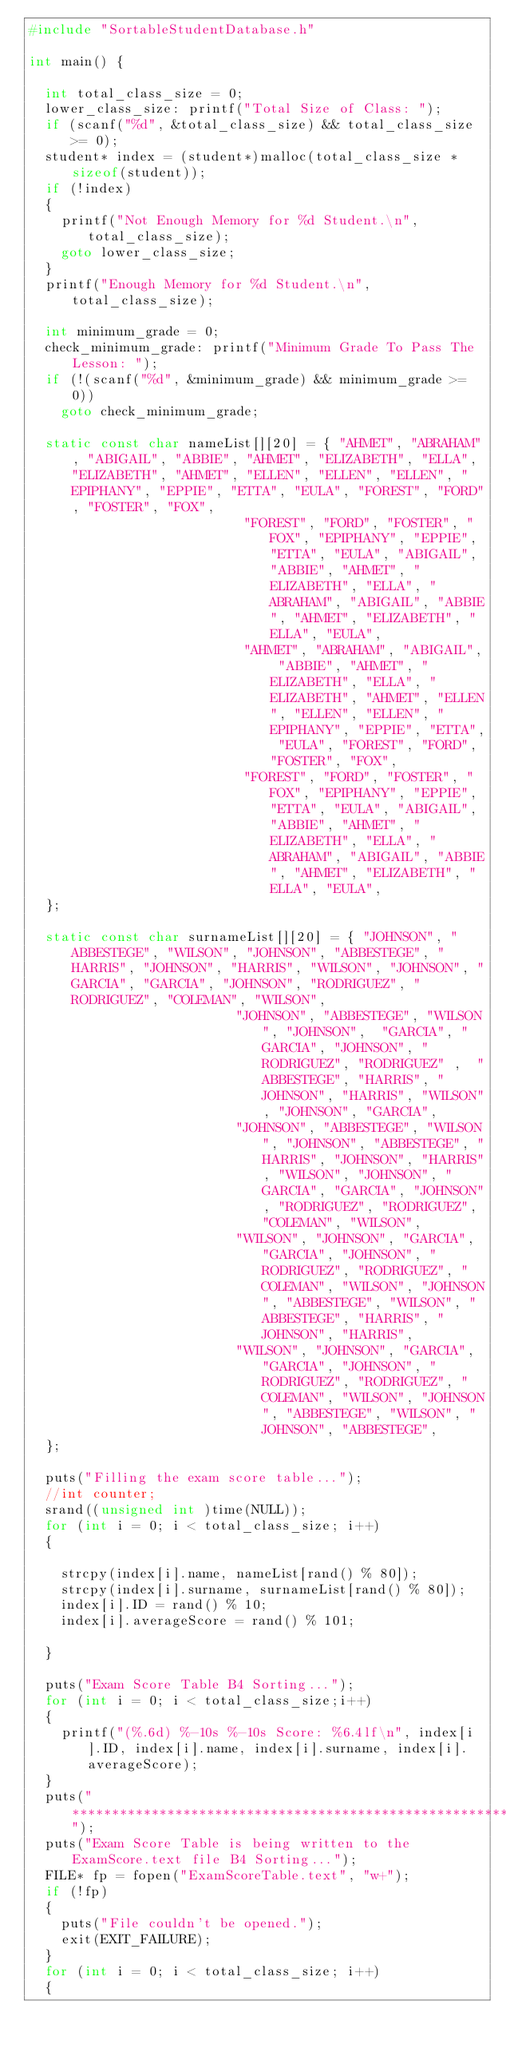Convert code to text. <code><loc_0><loc_0><loc_500><loc_500><_C_>#include "SortableStudentDatabase.h"

int main() {

	int total_class_size = 0;
	lower_class_size: printf("Total Size of Class: ");
	if (scanf("%d", &total_class_size) && total_class_size >= 0);
	student* index = (student*)malloc(total_class_size * sizeof(student));
	if (!index)
	{
		printf("Not Enough Memory for %d Student.\n", total_class_size);
		goto lower_class_size;
	}
	printf("Enough Memory for %d Student.\n", total_class_size);

	int minimum_grade = 0;
	check_minimum_grade: printf("Minimum Grade To Pass The Lesson: ");
	if (!(scanf("%d", &minimum_grade) && minimum_grade >= 0))
		goto check_minimum_grade;

	static const char nameList[][20] = { "AHMET", "ABRAHAM", "ABIGAIL", "ABBIE", "AHMET", "ELIZABETH", "ELLA", "ELIZABETH", "AHMET", "ELLEN", "ELLEN", "ELLEN", "EPIPHANY", "EPPIE", "ETTA", "EULA", "FOREST", "FORD", "FOSTER", "FOX",
										       "FOREST", "FORD", "FOSTER", "FOX", "EPIPHANY", "EPPIE", "ETTA", "EULA", "ABIGAIL", "ABBIE", "AHMET", "ELIZABETH", "ELLA", "ABRAHAM", "ABIGAIL", "ABBIE", "AHMET", "ELIZABETH", "ELLA", "EULA",
										       "AHMET", "ABRAHAM", "ABIGAIL", "ABBIE", "AHMET", "ELIZABETH", "ELLA", "ELIZABETH", "AHMET", "ELLEN", "ELLEN", "ELLEN", "EPIPHANY", "EPPIE", "ETTA", "EULA", "FOREST", "FORD", "FOSTER", "FOX",
										       "FOREST", "FORD", "FOSTER", "FOX", "EPIPHANY", "EPPIE", "ETTA", "EULA", "ABIGAIL", "ABBIE", "AHMET", "ELIZABETH", "ELLA", "ABRAHAM", "ABIGAIL", "ABBIE", "AHMET", "ELIZABETH", "ELLA", "EULA", 
	};

	static const char surnameList[][20] = { "JOHNSON", "ABBESTEGE", "WILSON", "JOHNSON", "ABBESTEGE", "HARRIS", "JOHNSON", "HARRIS", "WILSON", "JOHNSON", "GARCIA", "GARCIA", "JOHNSON", "RODRIGUEZ", "RODRIGUEZ", "COLEMAN", "WILSON",
												  "JOHNSON", "ABBESTEGE", "WILSON", "JOHNSON",	"GARCIA", "GARCIA", "JOHNSON", "RODRIGUEZ", "RODRIGUEZ"	,  "ABBESTEGE", "HARRIS", "JOHNSON", "HARRIS", "WILSON", "JOHNSON", "GARCIA",
												  "JOHNSON", "ABBESTEGE", "WILSON", "JOHNSON", "ABBESTEGE", "HARRIS", "JOHNSON", "HARRIS", "WILSON", "JOHNSON", "GARCIA", "GARCIA", "JOHNSON", "RODRIGUEZ", "RODRIGUEZ", "COLEMAN", "WILSON",
												  "WILSON", "JOHNSON", "GARCIA", "GARCIA", "JOHNSON", "RODRIGUEZ", "RODRIGUEZ", "COLEMAN", "WILSON", "JOHNSON", "ABBESTEGE", "WILSON", "ABBESTEGE", "HARRIS", "JOHNSON", "HARRIS",
												  "WILSON", "JOHNSON", "GARCIA", "GARCIA", "JOHNSON", "RODRIGUEZ", "RODRIGUEZ", "COLEMAN", "WILSON", "JOHNSON", "ABBESTEGE", "WILSON", "JOHNSON", "ABBESTEGE",
	};

	puts("Filling the exam score table...");
	//int counter;
	srand((unsigned int	)time(NULL));
	for (int i = 0; i < total_class_size; i++)
	{
		
		strcpy(index[i].name, nameList[rand() % 80]);
		strcpy(index[i].surname, surnameList[rand() % 80]);
		index[i].ID = rand() % 10;
		index[i].averageScore = rand() % 101;
		
	}

	puts("Exam Score Table B4 Sorting...");
	for (int i = 0; i < total_class_size;i++)
	{
		printf("(%.6d) %-10s %-10s Score: %6.4lf\n", index[i].ID, index[i].name, index[i].surname, index[i].averageScore);
	}
	puts("***************************************************************************");
	puts("Exam Score Table is being written to the ExamScore.text file B4 Sorting...");
	FILE* fp = fopen("ExamScoreTable.text", "w+");
	if (!fp)
	{
		puts("File couldn't be opened.");
		exit(EXIT_FAILURE);
	}
	for (int i = 0; i < total_class_size; i++)
	{</code> 